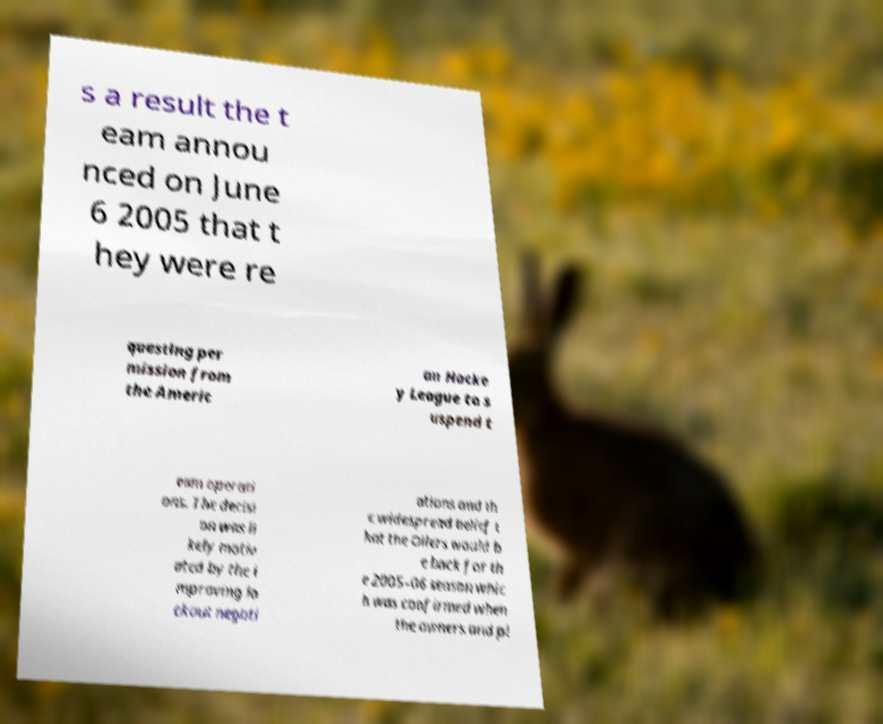Could you extract and type out the text from this image? s a result the t eam annou nced on June 6 2005 that t hey were re questing per mission from the Americ an Hocke y League to s uspend t eam operati ons. The decisi on was li kely motiv ated by the i mproving lo ckout negoti ations and th e widespread belief t hat the Oilers would b e back for th e 2005–06 season whic h was confirmed when the owners and pl 